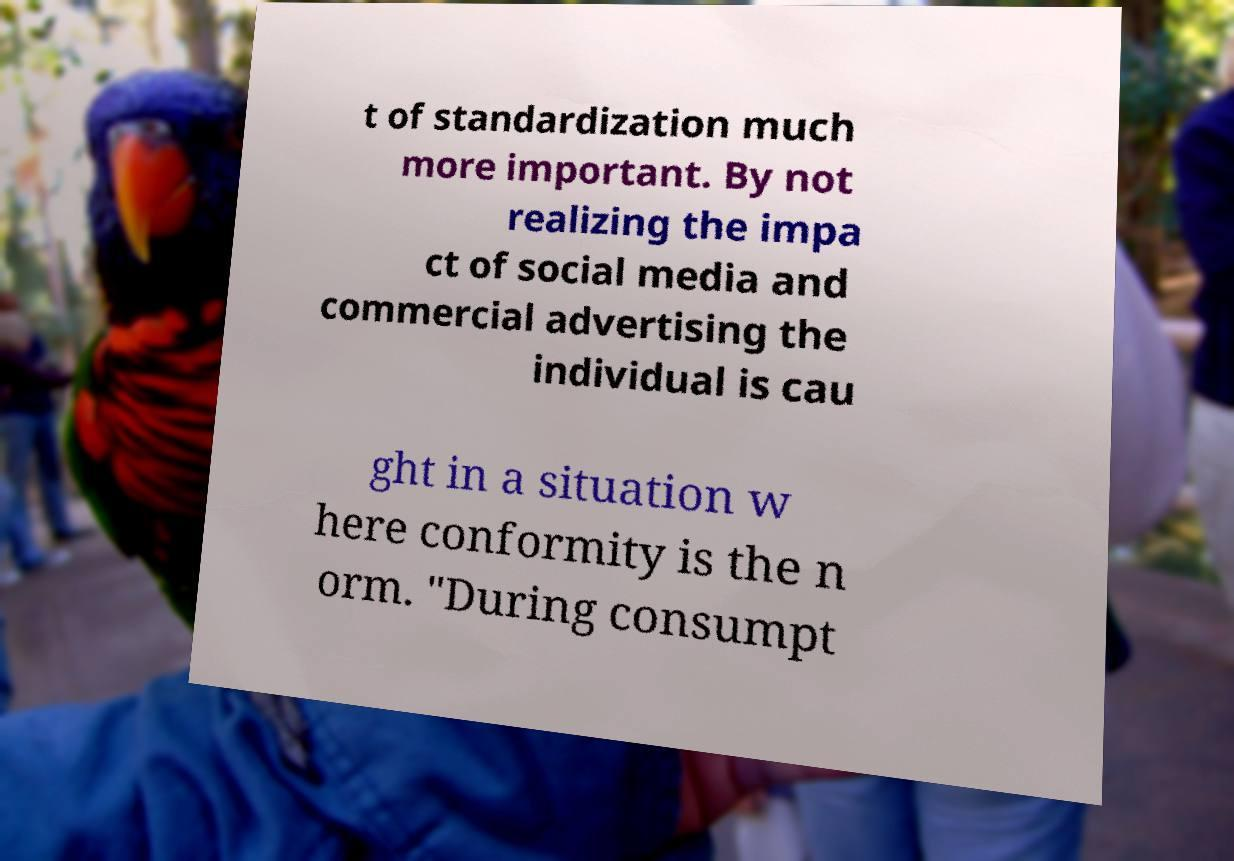Please read and relay the text visible in this image. What does it say? t of standardization much more important. By not realizing the impa ct of social media and commercial advertising the individual is cau ght in a situation w here conformity is the n orm. "During consumpt 